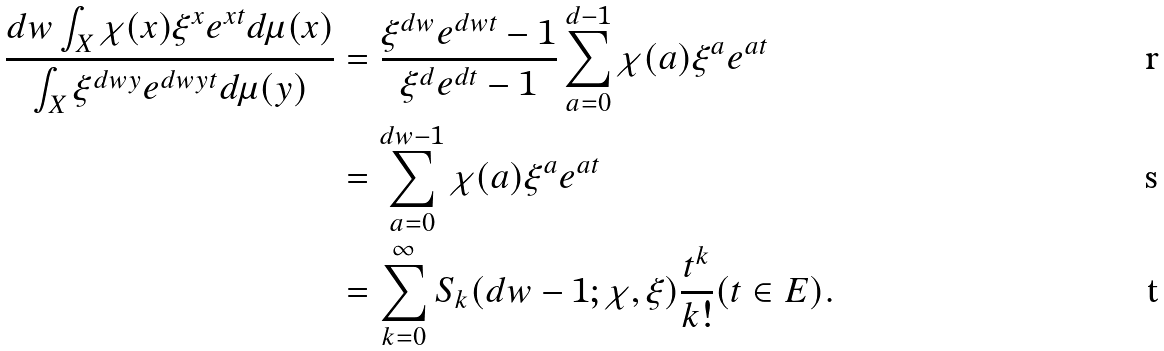Convert formula to latex. <formula><loc_0><loc_0><loc_500><loc_500>\frac { d w \int _ { X } \chi ( x ) \xi ^ { x } e ^ { x t } d \mu ( x ) } { \int _ { X } \xi ^ { d w y } e ^ { d w y t } d \mu ( y ) } & = \frac { \xi ^ { d w } e ^ { d w t } - 1 } { \xi ^ { d } e ^ { d t } - 1 } \sum _ { a = 0 } ^ { d - 1 } \chi ( a ) \xi ^ { a } e ^ { a t } \\ & = \sum _ { a = 0 } ^ { d w - 1 } \chi ( a ) \xi ^ { a } e ^ { a t } \\ & = \sum _ { k = 0 } ^ { \infty } S _ { k } ( d w - 1 ; \chi , \xi ) \frac { t ^ { k } } { k ! } ( t \in E ) .</formula> 